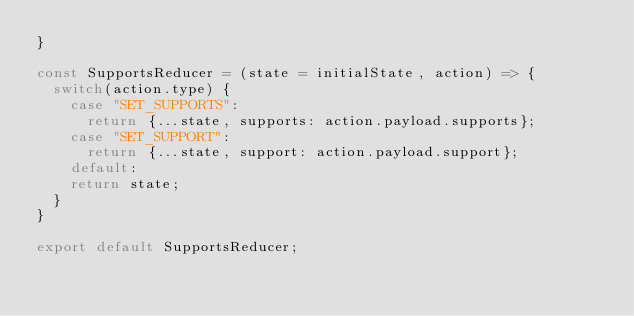<code> <loc_0><loc_0><loc_500><loc_500><_JavaScript_>}

const SupportsReducer = (state = initialState, action) => {
  switch(action.type) {
    case "SET_SUPPORTS":
      return {...state, supports: action.payload.supports};
    case "SET_SUPPORT":
      return {...state, support: action.payload.support};
    default: 
    return state;
  }
}

export default SupportsReducer;</code> 